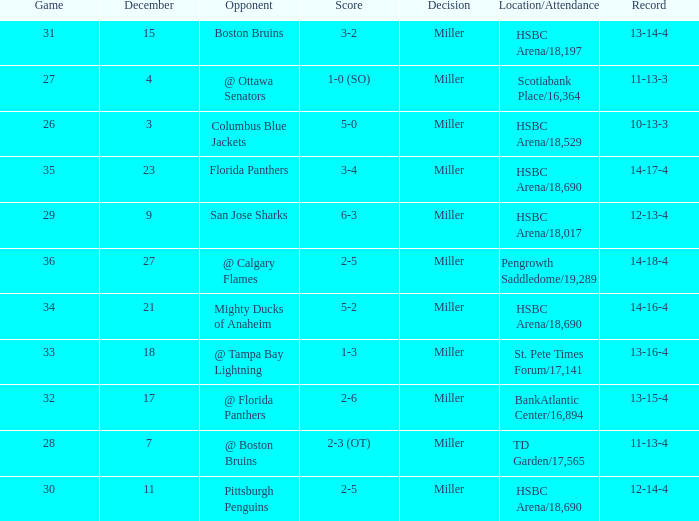Could you parse the entire table? {'header': ['Game', 'December', 'Opponent', 'Score', 'Decision', 'Location/Attendance', 'Record'], 'rows': [['31', '15', 'Boston Bruins', '3-2', 'Miller', 'HSBC Arena/18,197', '13-14-4'], ['27', '4', '@ Ottawa Senators', '1-0 (SO)', 'Miller', 'Scotiabank Place/16,364', '11-13-3'], ['26', '3', 'Columbus Blue Jackets', '5-0', 'Miller', 'HSBC Arena/18,529', '10-13-3'], ['35', '23', 'Florida Panthers', '3-4', 'Miller', 'HSBC Arena/18,690', '14-17-4'], ['29', '9', 'San Jose Sharks', '6-3', 'Miller', 'HSBC Arena/18,017', '12-13-4'], ['36', '27', '@ Calgary Flames', '2-5', 'Miller', 'Pengrowth Saddledome/19,289', '14-18-4'], ['34', '21', 'Mighty Ducks of Anaheim', '5-2', 'Miller', 'HSBC Arena/18,690', '14-16-4'], ['33', '18', '@ Tampa Bay Lightning', '1-3', 'Miller', 'St. Pete Times Forum/17,141', '13-16-4'], ['32', '17', '@ Florida Panthers', '2-6', 'Miller', 'BankAtlantic Center/16,894', '13-15-4'], ['28', '7', '@ Boston Bruins', '2-3 (OT)', 'Miller', 'TD Garden/17,565', '11-13-4'], ['30', '11', 'Pittsburgh Penguins', '2-5', 'Miller', 'HSBC Arena/18,690', '12-14-4']]} Name the least december for hsbc arena/18,017 9.0. 